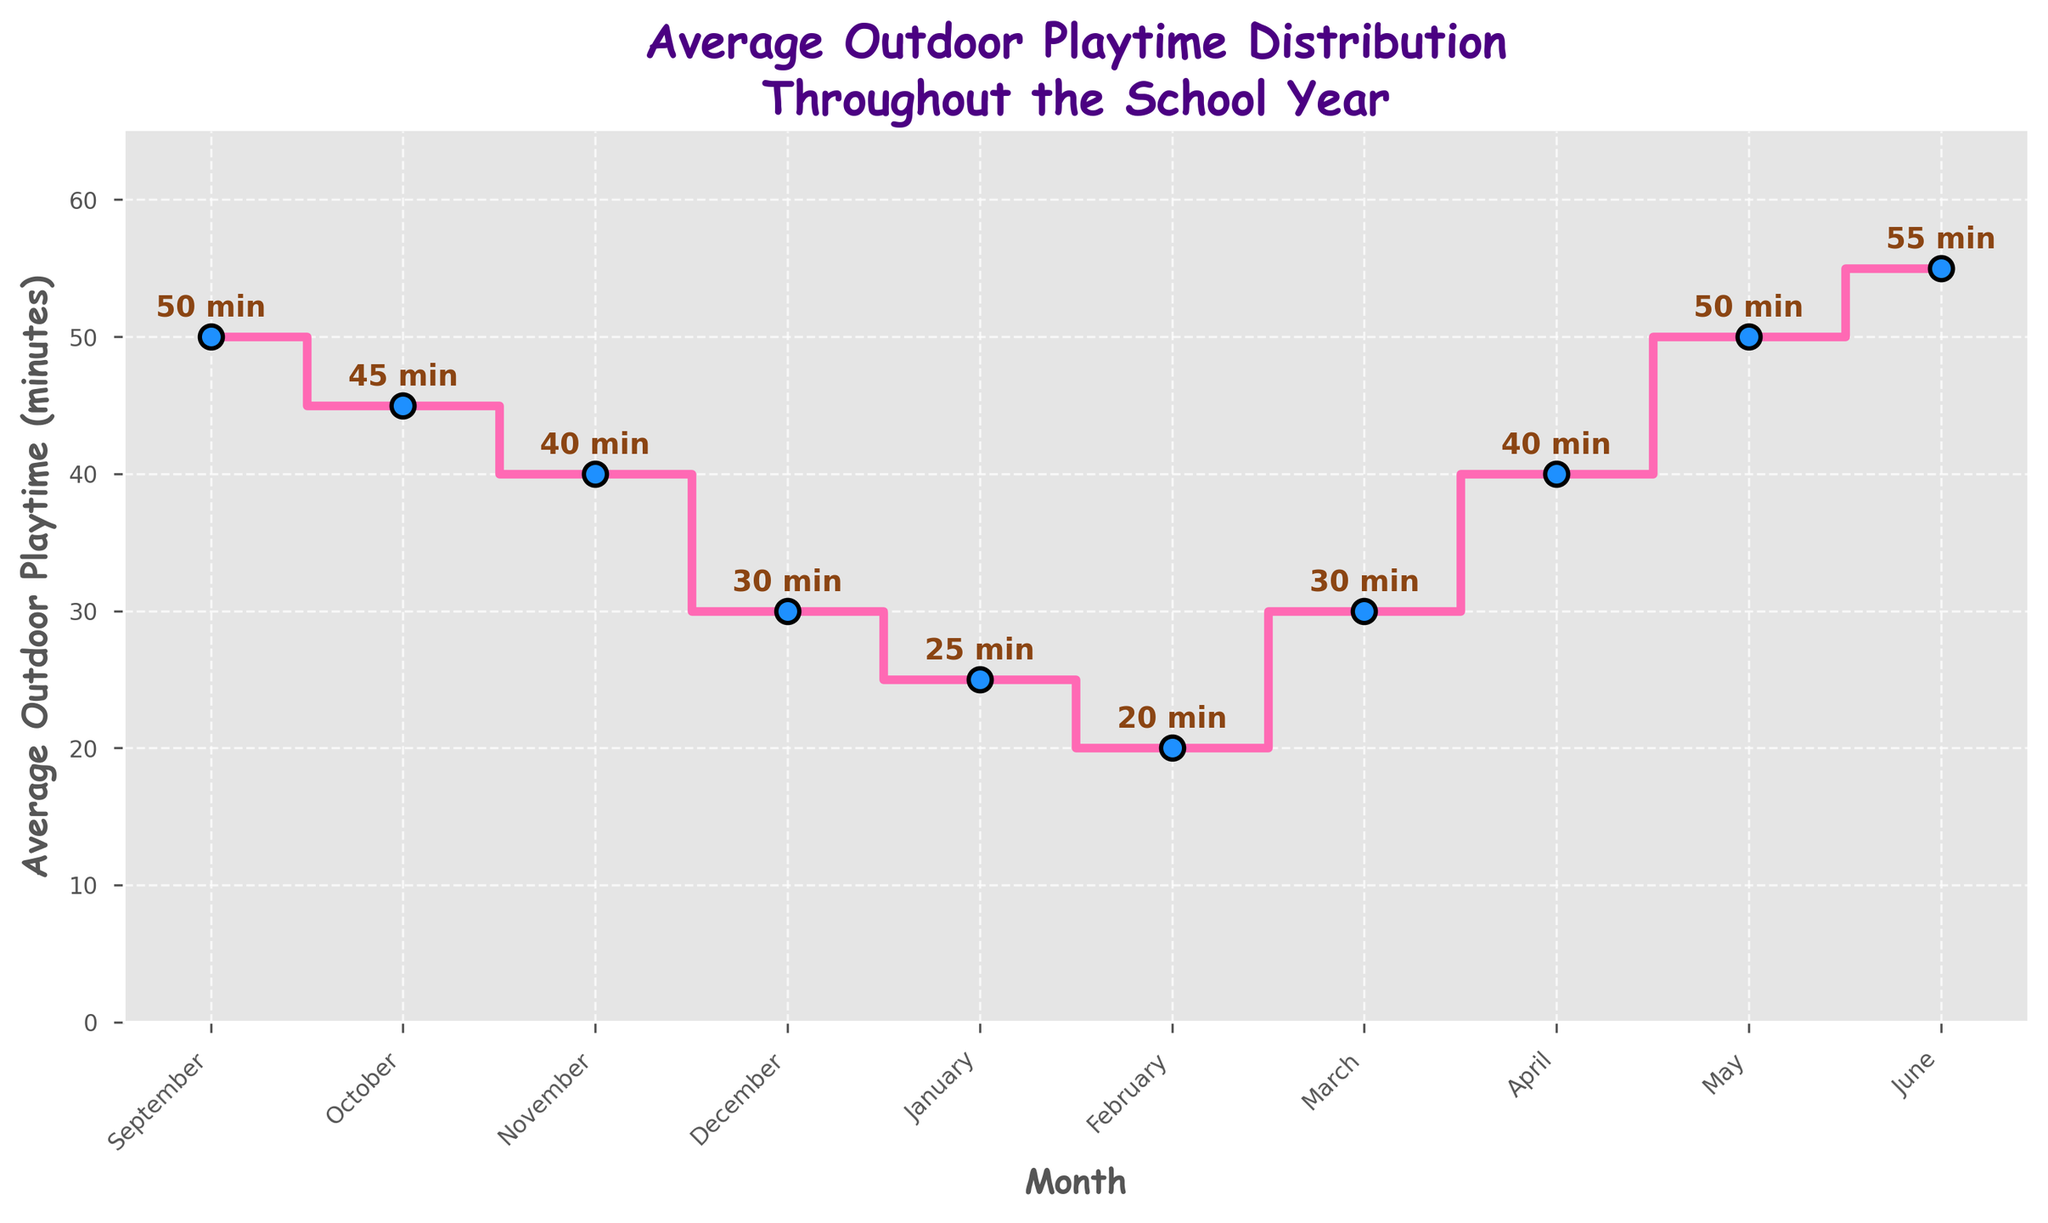How many months are displayed on the plot? The plot shows data points corresponding to each month, indicating the time frame covered by the plot. By counting these data points, we can determine the total number of months displayed.
Answer: 10 months What is the title of the plot? The title is found at the top of the plot, providing an overview of what the data represents. It typically summarizes the main insight or data aspect being shown.
Answer: Average Outdoor Playtime Distribution Throughout the School Year During which month is the average outdoor playtime at its lowest? By examining the plot and identifying the point with the lowest value on the y-axis, we can pinpoint the month with the minimum average outdoor playtime.
Answer: February What is the difference in average outdoor playtime between September and January? To find the difference, we need to locate the values for September (50 minutes) and January (25 minutes) from the plot and subtract the January value from the September value.
Answer: 25 minutes What is the total average outdoor playtime for the months of November, December, and January? We find the playtime values for November (40 minutes), December (30 minutes), and January (25 minutes) and sum them up: 40 + 30 + 25.
Answer: 95 minutes Which month has a higher average outdoor playtime, March or April? By comparing the data points for March (30 minutes) and April (40 minutes), we determine which one is greater.
Answer: April How does the average outdoor playtime trend from January to June? Observing the plot from January through June, we see the trend of average outdoor playtime by noting how the values change over these months (increasing, decreasing, or remaining stable).
Answer: Increasing What is the average outdoor playtime for the first half of the school year (September to February)? We locate the values for the months from September to February (50, 45, 40, 30, 25, 20) and calculate their average: (50 + 45 + 40 + 30 + 25 + 20) / 6.
Answer: 35 minutes During which months does the average outdoor playtime stay the same? By identifying months on the plot where the playtime values are identical, we can determine periods with no change.
Answer: None What happens to the outdoor playtime from May to June? We compare the values for May (50 minutes) and June (55 minutes) to see if there is an increase, decrease, or no change.
Answer: It increases 